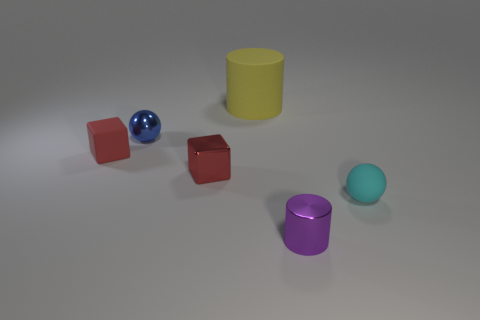What materials are the objects in the image made of, and which one appears the most reflective? The objects in the image seem to have a variety of materials. The two cubes and the sphere appear to be metallic due to their shiny surfaces, which suggests they are good reflectors of light. The cylinder appears to be made of a matte finish material, possibly plastic. Among them, the blue metallic sphere has the most reflective surface, as indicated by the bright spots of light visible on its surface. 